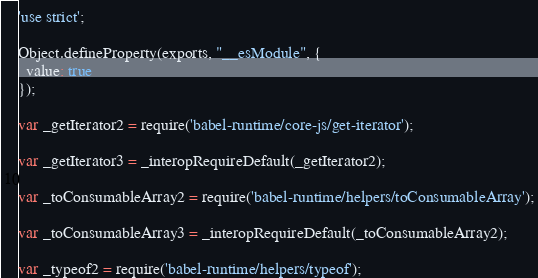<code> <loc_0><loc_0><loc_500><loc_500><_JavaScript_>'use strict';

Object.defineProperty(exports, "__esModule", {
  value: true
});

var _getIterator2 = require('babel-runtime/core-js/get-iterator');

var _getIterator3 = _interopRequireDefault(_getIterator2);

var _toConsumableArray2 = require('babel-runtime/helpers/toConsumableArray');

var _toConsumableArray3 = _interopRequireDefault(_toConsumableArray2);

var _typeof2 = require('babel-runtime/helpers/typeof');
</code> 